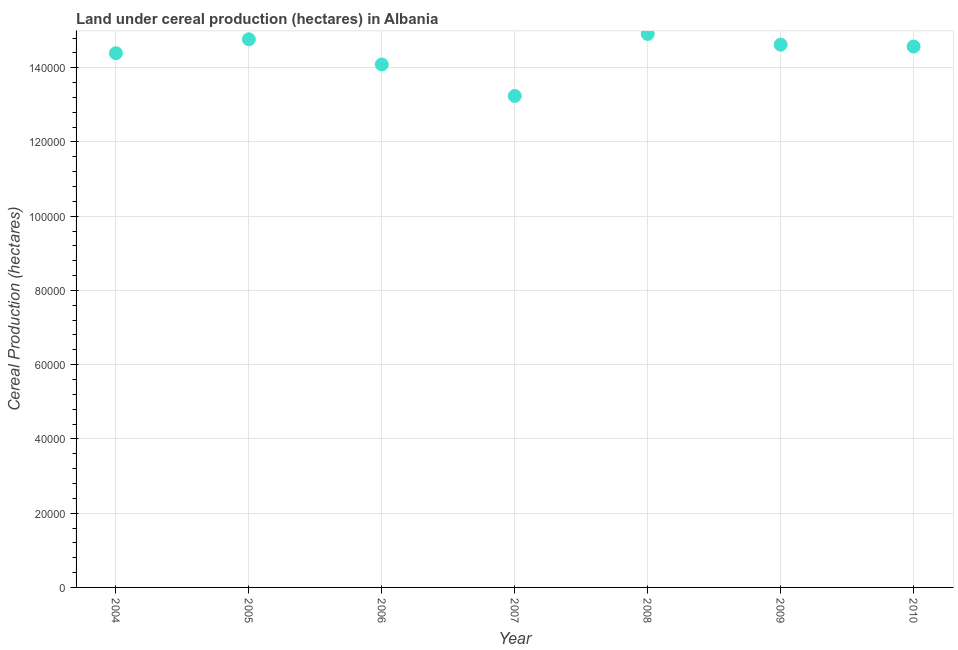What is the land under cereal production in 2008?
Your answer should be very brief. 1.49e+05. Across all years, what is the maximum land under cereal production?
Your response must be concise. 1.49e+05. Across all years, what is the minimum land under cereal production?
Offer a very short reply. 1.32e+05. In which year was the land under cereal production minimum?
Ensure brevity in your answer.  2007. What is the sum of the land under cereal production?
Provide a succinct answer. 1.01e+06. What is the difference between the land under cereal production in 2006 and 2009?
Offer a very short reply. -5330. What is the average land under cereal production per year?
Your answer should be compact. 1.44e+05. What is the median land under cereal production?
Your answer should be very brief. 1.46e+05. What is the ratio of the land under cereal production in 2006 to that in 2007?
Your answer should be compact. 1.06. What is the difference between the highest and the second highest land under cereal production?
Make the answer very short. 1445. What is the difference between the highest and the lowest land under cereal production?
Ensure brevity in your answer.  1.67e+04. In how many years, is the land under cereal production greater than the average land under cereal production taken over all years?
Ensure brevity in your answer.  5. Does the land under cereal production monotonically increase over the years?
Make the answer very short. No. How many years are there in the graph?
Your answer should be compact. 7. Does the graph contain grids?
Provide a succinct answer. Yes. What is the title of the graph?
Give a very brief answer. Land under cereal production (hectares) in Albania. What is the label or title of the Y-axis?
Your response must be concise. Cereal Production (hectares). What is the Cereal Production (hectares) in 2004?
Your answer should be very brief. 1.44e+05. What is the Cereal Production (hectares) in 2005?
Provide a succinct answer. 1.48e+05. What is the Cereal Production (hectares) in 2006?
Offer a terse response. 1.41e+05. What is the Cereal Production (hectares) in 2007?
Make the answer very short. 1.32e+05. What is the Cereal Production (hectares) in 2008?
Offer a terse response. 1.49e+05. What is the Cereal Production (hectares) in 2009?
Your response must be concise. 1.46e+05. What is the Cereal Production (hectares) in 2010?
Your answer should be very brief. 1.46e+05. What is the difference between the Cereal Production (hectares) in 2004 and 2005?
Keep it short and to the point. -3755. What is the difference between the Cereal Production (hectares) in 2004 and 2006?
Offer a very short reply. 3030. What is the difference between the Cereal Production (hectares) in 2004 and 2007?
Your answer should be very brief. 1.15e+04. What is the difference between the Cereal Production (hectares) in 2004 and 2008?
Offer a terse response. -5200. What is the difference between the Cereal Production (hectares) in 2004 and 2009?
Make the answer very short. -2300. What is the difference between the Cereal Production (hectares) in 2004 and 2010?
Your answer should be compact. -1800. What is the difference between the Cereal Production (hectares) in 2005 and 2006?
Your answer should be compact. 6785. What is the difference between the Cereal Production (hectares) in 2005 and 2007?
Offer a terse response. 1.53e+04. What is the difference between the Cereal Production (hectares) in 2005 and 2008?
Ensure brevity in your answer.  -1445. What is the difference between the Cereal Production (hectares) in 2005 and 2009?
Keep it short and to the point. 1455. What is the difference between the Cereal Production (hectares) in 2005 and 2010?
Provide a short and direct response. 1955. What is the difference between the Cereal Production (hectares) in 2006 and 2007?
Your answer should be very brief. 8480. What is the difference between the Cereal Production (hectares) in 2006 and 2008?
Provide a succinct answer. -8230. What is the difference between the Cereal Production (hectares) in 2006 and 2009?
Offer a very short reply. -5330. What is the difference between the Cereal Production (hectares) in 2006 and 2010?
Ensure brevity in your answer.  -4830. What is the difference between the Cereal Production (hectares) in 2007 and 2008?
Offer a terse response. -1.67e+04. What is the difference between the Cereal Production (hectares) in 2007 and 2009?
Provide a short and direct response. -1.38e+04. What is the difference between the Cereal Production (hectares) in 2007 and 2010?
Make the answer very short. -1.33e+04. What is the difference between the Cereal Production (hectares) in 2008 and 2009?
Offer a terse response. 2900. What is the difference between the Cereal Production (hectares) in 2008 and 2010?
Provide a succinct answer. 3400. What is the difference between the Cereal Production (hectares) in 2009 and 2010?
Your answer should be compact. 500. What is the ratio of the Cereal Production (hectares) in 2004 to that in 2007?
Offer a very short reply. 1.09. What is the ratio of the Cereal Production (hectares) in 2004 to that in 2008?
Offer a terse response. 0.96. What is the ratio of the Cereal Production (hectares) in 2005 to that in 2006?
Your answer should be compact. 1.05. What is the ratio of the Cereal Production (hectares) in 2005 to that in 2007?
Your response must be concise. 1.11. What is the ratio of the Cereal Production (hectares) in 2005 to that in 2009?
Provide a short and direct response. 1.01. What is the ratio of the Cereal Production (hectares) in 2006 to that in 2007?
Provide a short and direct response. 1.06. What is the ratio of the Cereal Production (hectares) in 2006 to that in 2008?
Provide a short and direct response. 0.94. What is the ratio of the Cereal Production (hectares) in 2007 to that in 2008?
Offer a very short reply. 0.89. What is the ratio of the Cereal Production (hectares) in 2007 to that in 2009?
Your answer should be very brief. 0.91. What is the ratio of the Cereal Production (hectares) in 2007 to that in 2010?
Ensure brevity in your answer.  0.91. What is the ratio of the Cereal Production (hectares) in 2008 to that in 2009?
Offer a very short reply. 1.02. What is the ratio of the Cereal Production (hectares) in 2008 to that in 2010?
Offer a very short reply. 1.02. 